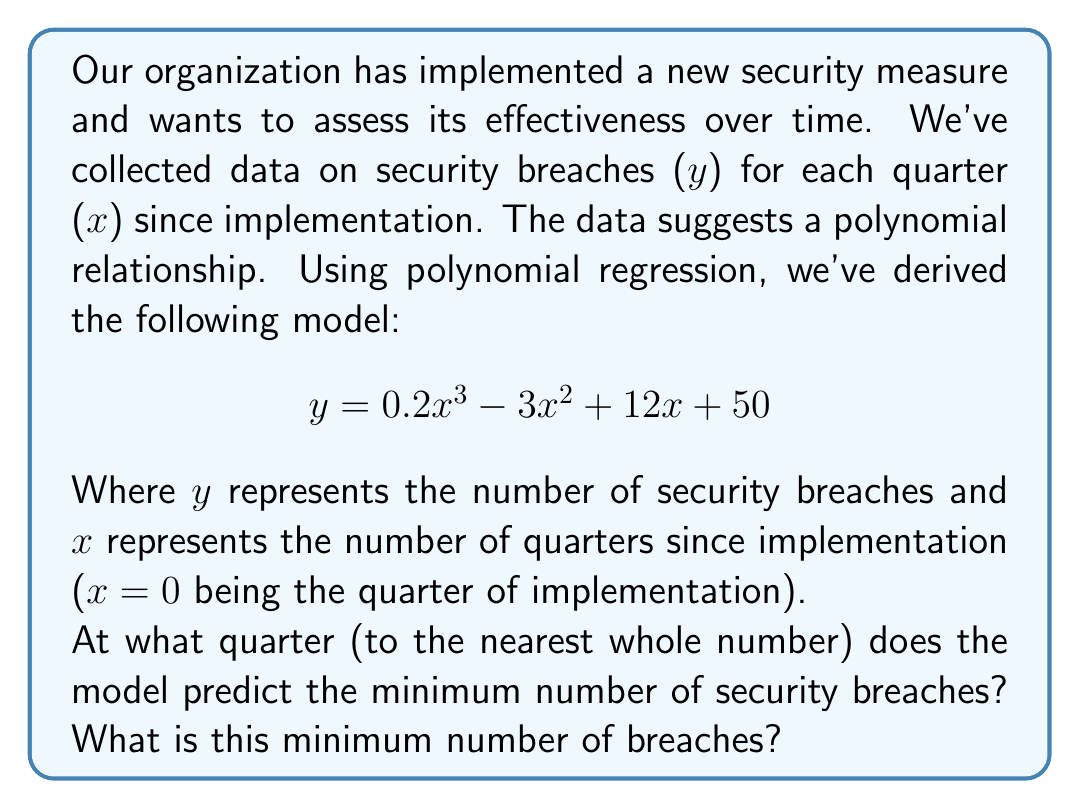Provide a solution to this math problem. To find the quarter with the minimum number of security breaches, we need to find the minimum point of the polynomial function. This can be done by following these steps:

1) First, we find the derivative of the function:
   $$ \frac{dy}{dx} = 0.6x^2 - 6x + 12 $$

2) Set the derivative to zero to find the critical points:
   $$ 0.6x^2 - 6x + 12 = 0 $$

3) This is a quadratic equation. We can solve it using the quadratic formula:
   $$ x = \frac{-b \pm \sqrt{b^2 - 4ac}}{2a} $$
   Where $a = 0.6$, $b = -6$, and $c = 12$

4) Plugging in these values:
   $$ x = \frac{6 \pm \sqrt{36 - 28.8}}{1.2} = \frac{6 \pm \sqrt{7.2}}{1.2} $$

5) Simplifying:
   $$ x = \frac{6 \pm 2.68}{1.2} $$

6) This gives us two critical points:
   $$ x_1 = \frac{6 + 2.68}{1.2} \approx 7.23 $$
   $$ x_2 = \frac{6 - 2.68}{1.2} \approx 2.77 $$

7) To determine which point is the minimum, we can check the second derivative:
   $$ \frac{d^2y}{dx^2} = 1.2x - 6 $$

8) At $x = 2.77$, the second derivative is positive, indicating a minimum.

9) Rounding to the nearest whole number, the minimum occurs at quarter 3.

10) To find the minimum number of breaches, we plug x = 3 into the original equation:
    $$ y = 0.2(3)^3 - 3(3)^2 + 12(3) + 50 = 5.4 - 27 + 36 + 50 = 64.4 $$

Therefore, the model predicts a minimum of approximately 64 security breaches.
Answer: The model predicts the minimum number of security breaches to occur at quarter 3, with approximately 64 breaches. 